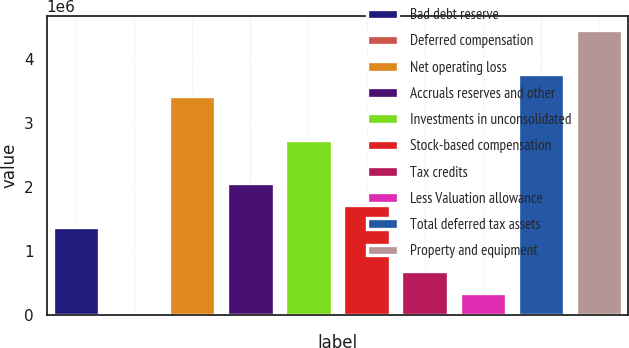Convert chart to OTSL. <chart><loc_0><loc_0><loc_500><loc_500><bar_chart><fcel>Bad debt reserve<fcel>Deferred compensation<fcel>Net operating loss<fcel>Accruals reserves and other<fcel>Investments in unconsolidated<fcel>Stock-based compensation<fcel>Tax credits<fcel>Less Valuation allowance<fcel>Total deferred tax assets<fcel>Property and equipment<nl><fcel>1.37061e+06<fcel>2895<fcel>3.42219e+06<fcel>2.05447e+06<fcel>2.73833e+06<fcel>1.71254e+06<fcel>686755<fcel>344825<fcel>3.76412e+06<fcel>4.44798e+06<nl></chart> 